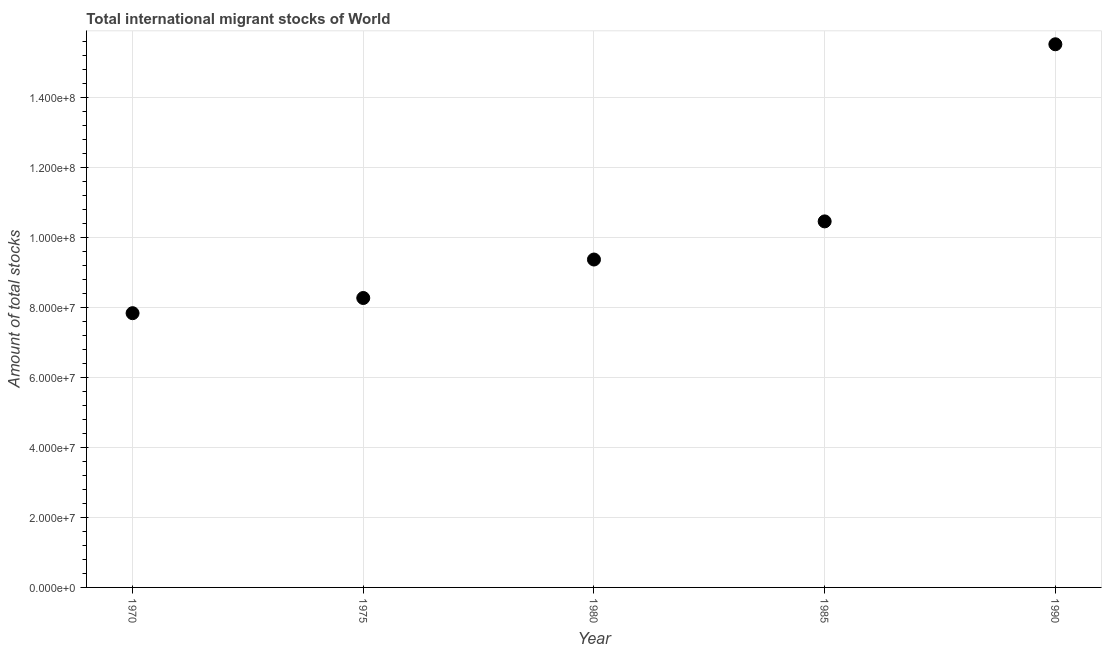What is the total number of international migrant stock in 1970?
Make the answer very short. 7.84e+07. Across all years, what is the maximum total number of international migrant stock?
Offer a terse response. 1.55e+08. Across all years, what is the minimum total number of international migrant stock?
Ensure brevity in your answer.  7.84e+07. In which year was the total number of international migrant stock maximum?
Offer a terse response. 1990. In which year was the total number of international migrant stock minimum?
Keep it short and to the point. 1970. What is the sum of the total number of international migrant stock?
Provide a succinct answer. 5.15e+08. What is the difference between the total number of international migrant stock in 1970 and 1975?
Your answer should be compact. -4.34e+06. What is the average total number of international migrant stock per year?
Provide a succinct answer. 1.03e+08. What is the median total number of international migrant stock?
Provide a succinct answer. 9.37e+07. What is the ratio of the total number of international migrant stock in 1980 to that in 1985?
Provide a short and direct response. 0.9. Is the total number of international migrant stock in 1970 less than that in 1980?
Offer a terse response. Yes. What is the difference between the highest and the second highest total number of international migrant stock?
Offer a terse response. 5.06e+07. What is the difference between the highest and the lowest total number of international migrant stock?
Provide a short and direct response. 7.68e+07. In how many years, is the total number of international migrant stock greater than the average total number of international migrant stock taken over all years?
Give a very brief answer. 2. Does the total number of international migrant stock monotonically increase over the years?
Offer a very short reply. Yes. How many years are there in the graph?
Offer a terse response. 5. Does the graph contain any zero values?
Ensure brevity in your answer.  No. Does the graph contain grids?
Your answer should be very brief. Yes. What is the title of the graph?
Offer a terse response. Total international migrant stocks of World. What is the label or title of the X-axis?
Provide a succinct answer. Year. What is the label or title of the Y-axis?
Provide a short and direct response. Amount of total stocks. What is the Amount of total stocks in 1970?
Keep it short and to the point. 7.84e+07. What is the Amount of total stocks in 1975?
Give a very brief answer. 8.27e+07. What is the Amount of total stocks in 1980?
Your response must be concise. 9.37e+07. What is the Amount of total stocks in 1985?
Your response must be concise. 1.05e+08. What is the Amount of total stocks in 1990?
Your response must be concise. 1.55e+08. What is the difference between the Amount of total stocks in 1970 and 1975?
Keep it short and to the point. -4.34e+06. What is the difference between the Amount of total stocks in 1970 and 1980?
Ensure brevity in your answer.  -1.53e+07. What is the difference between the Amount of total stocks in 1970 and 1985?
Offer a terse response. -2.62e+07. What is the difference between the Amount of total stocks in 1970 and 1990?
Offer a terse response. -7.68e+07. What is the difference between the Amount of total stocks in 1975 and 1980?
Give a very brief answer. -1.10e+07. What is the difference between the Amount of total stocks in 1975 and 1985?
Ensure brevity in your answer.  -2.19e+07. What is the difference between the Amount of total stocks in 1975 and 1990?
Keep it short and to the point. -7.25e+07. What is the difference between the Amount of total stocks in 1980 and 1985?
Offer a terse response. -1.09e+07. What is the difference between the Amount of total stocks in 1980 and 1990?
Provide a succinct answer. -6.15e+07. What is the difference between the Amount of total stocks in 1985 and 1990?
Offer a very short reply. -5.06e+07. What is the ratio of the Amount of total stocks in 1970 to that in 1975?
Offer a terse response. 0.95. What is the ratio of the Amount of total stocks in 1970 to that in 1980?
Provide a short and direct response. 0.84. What is the ratio of the Amount of total stocks in 1970 to that in 1985?
Ensure brevity in your answer.  0.75. What is the ratio of the Amount of total stocks in 1970 to that in 1990?
Ensure brevity in your answer.  0.51. What is the ratio of the Amount of total stocks in 1975 to that in 1980?
Your answer should be very brief. 0.88. What is the ratio of the Amount of total stocks in 1975 to that in 1985?
Offer a terse response. 0.79. What is the ratio of the Amount of total stocks in 1975 to that in 1990?
Offer a very short reply. 0.53. What is the ratio of the Amount of total stocks in 1980 to that in 1985?
Provide a succinct answer. 0.9. What is the ratio of the Amount of total stocks in 1980 to that in 1990?
Ensure brevity in your answer.  0.6. What is the ratio of the Amount of total stocks in 1985 to that in 1990?
Provide a short and direct response. 0.67. 